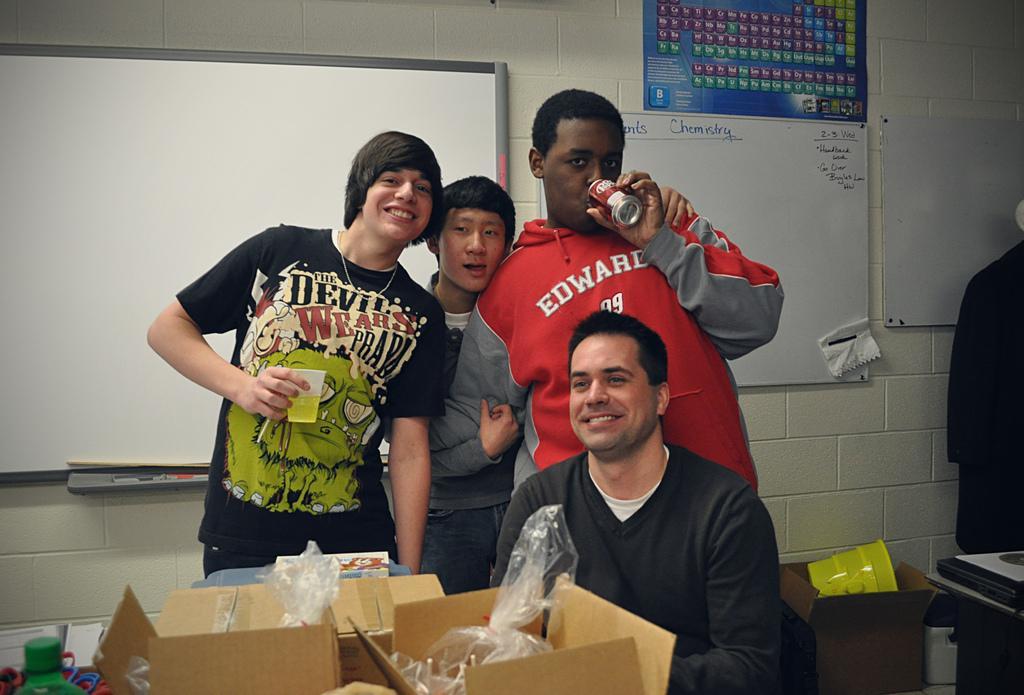Please provide a concise description of this image. In this picture we can see four people where a man sitting on a chair and smiling and two are holding a glass, tin with their hands and in front of them we can see boxes, papers, plastic covers and at the back of them we can see clothes, boards and posters on the wall, table and some objects. 